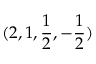<formula> <loc_0><loc_0><loc_500><loc_500>( 2 , 1 , \frac { 1 } { 2 } , - \frac { 1 } { 2 } )</formula> 